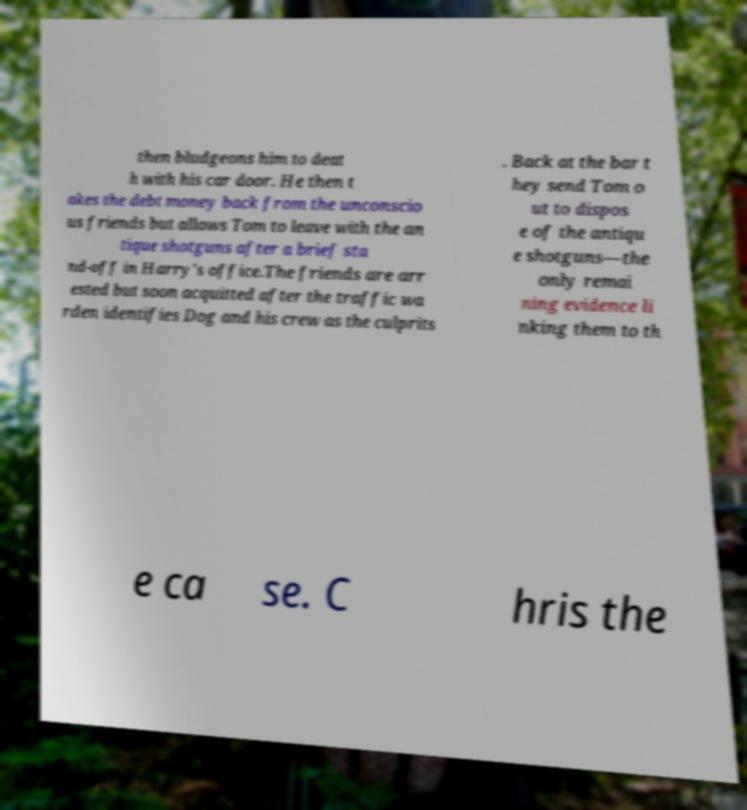For documentation purposes, I need the text within this image transcribed. Could you provide that? then bludgeons him to deat h with his car door. He then t akes the debt money back from the unconscio us friends but allows Tom to leave with the an tique shotguns after a brief sta nd-off in Harry's office.The friends are arr ested but soon acquitted after the traffic wa rden identifies Dog and his crew as the culprits . Back at the bar t hey send Tom o ut to dispos e of the antiqu e shotguns—the only remai ning evidence li nking them to th e ca se. C hris the 